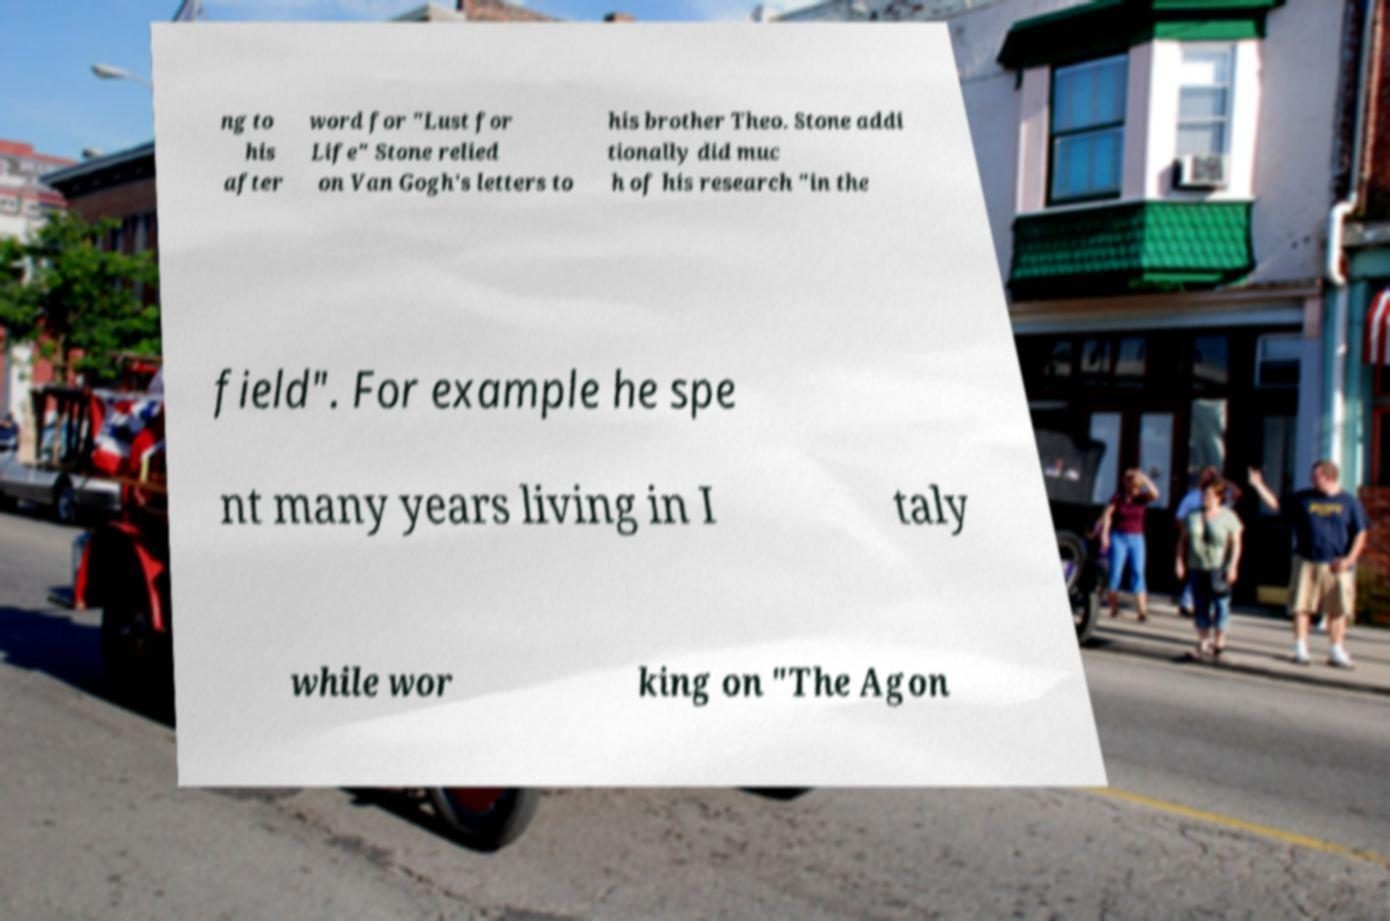For documentation purposes, I need the text within this image transcribed. Could you provide that? ng to his after word for "Lust for Life" Stone relied on Van Gogh's letters to his brother Theo. Stone addi tionally did muc h of his research "in the field". For example he spe nt many years living in I taly while wor king on "The Agon 